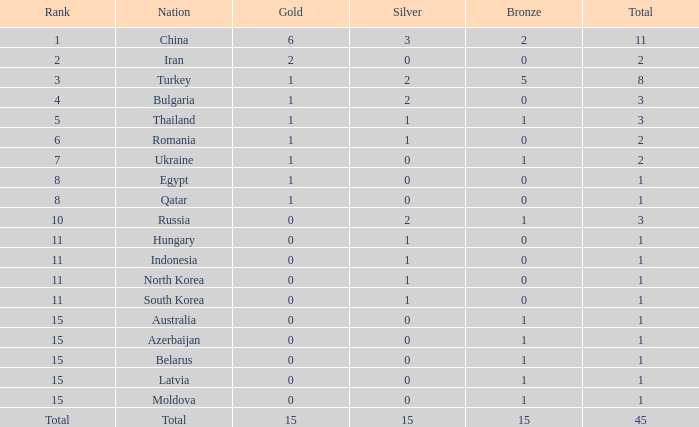Wha is the average number of bronze of hungary, which has less than 1 silver? None. Parse the full table. {'header': ['Rank', 'Nation', 'Gold', 'Silver', 'Bronze', 'Total'], 'rows': [['1', 'China', '6', '3', '2', '11'], ['2', 'Iran', '2', '0', '0', '2'], ['3', 'Turkey', '1', '2', '5', '8'], ['4', 'Bulgaria', '1', '2', '0', '3'], ['5', 'Thailand', '1', '1', '1', '3'], ['6', 'Romania', '1', '1', '0', '2'], ['7', 'Ukraine', '1', '0', '1', '2'], ['8', 'Egypt', '1', '0', '0', '1'], ['8', 'Qatar', '1', '0', '0', '1'], ['10', 'Russia', '0', '2', '1', '3'], ['11', 'Hungary', '0', '1', '0', '1'], ['11', 'Indonesia', '0', '1', '0', '1'], ['11', 'North Korea', '0', '1', '0', '1'], ['11', 'South Korea', '0', '1', '0', '1'], ['15', 'Australia', '0', '0', '1', '1'], ['15', 'Azerbaijan', '0', '0', '1', '1'], ['15', 'Belarus', '0', '0', '1', '1'], ['15', 'Latvia', '0', '0', '1', '1'], ['15', 'Moldova', '0', '0', '1', '1'], ['Total', 'Total', '15', '15', '15', '45']]} 